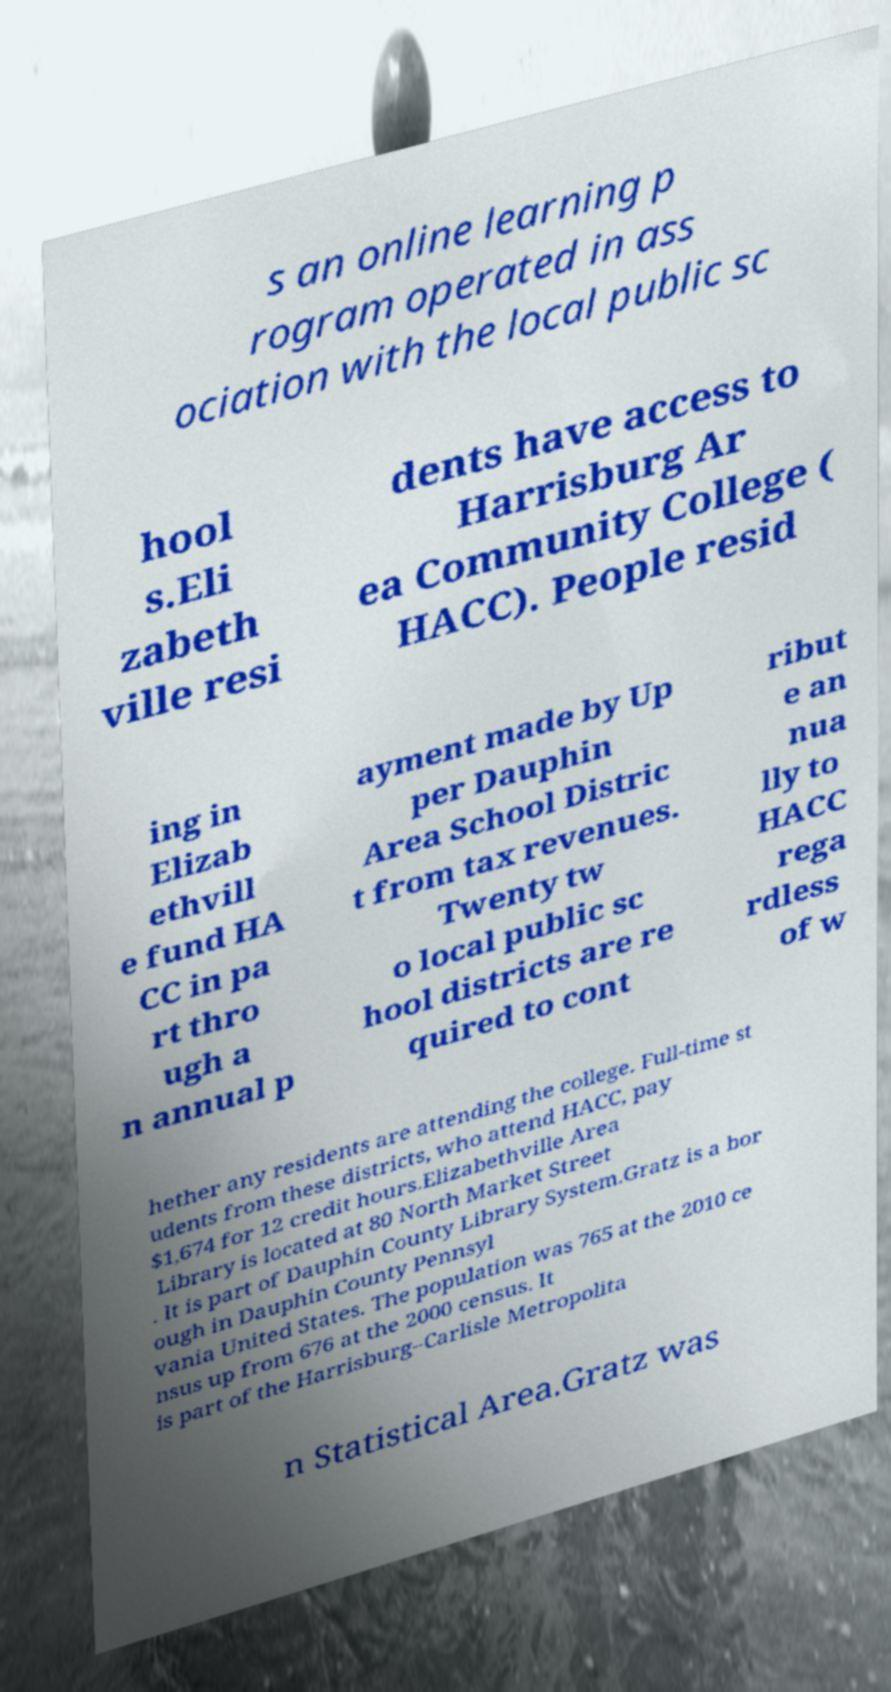For documentation purposes, I need the text within this image transcribed. Could you provide that? s an online learning p rogram operated in ass ociation with the local public sc hool s.Eli zabeth ville resi dents have access to Harrisburg Ar ea Community College ( HACC). People resid ing in Elizab ethvill e fund HA CC in pa rt thro ugh a n annual p ayment made by Up per Dauphin Area School Distric t from tax revenues. Twenty tw o local public sc hool districts are re quired to cont ribut e an nua lly to HACC rega rdless of w hether any residents are attending the college. Full-time st udents from these districts, who attend HACC, pay $1,674 for 12 credit hours.Elizabethville Area Library is located at 80 North Market Street . It is part of Dauphin County Library System.Gratz is a bor ough in Dauphin County Pennsyl vania United States. The population was 765 at the 2010 ce nsus up from 676 at the 2000 census. It is part of the Harrisburg–Carlisle Metropolita n Statistical Area.Gratz was 